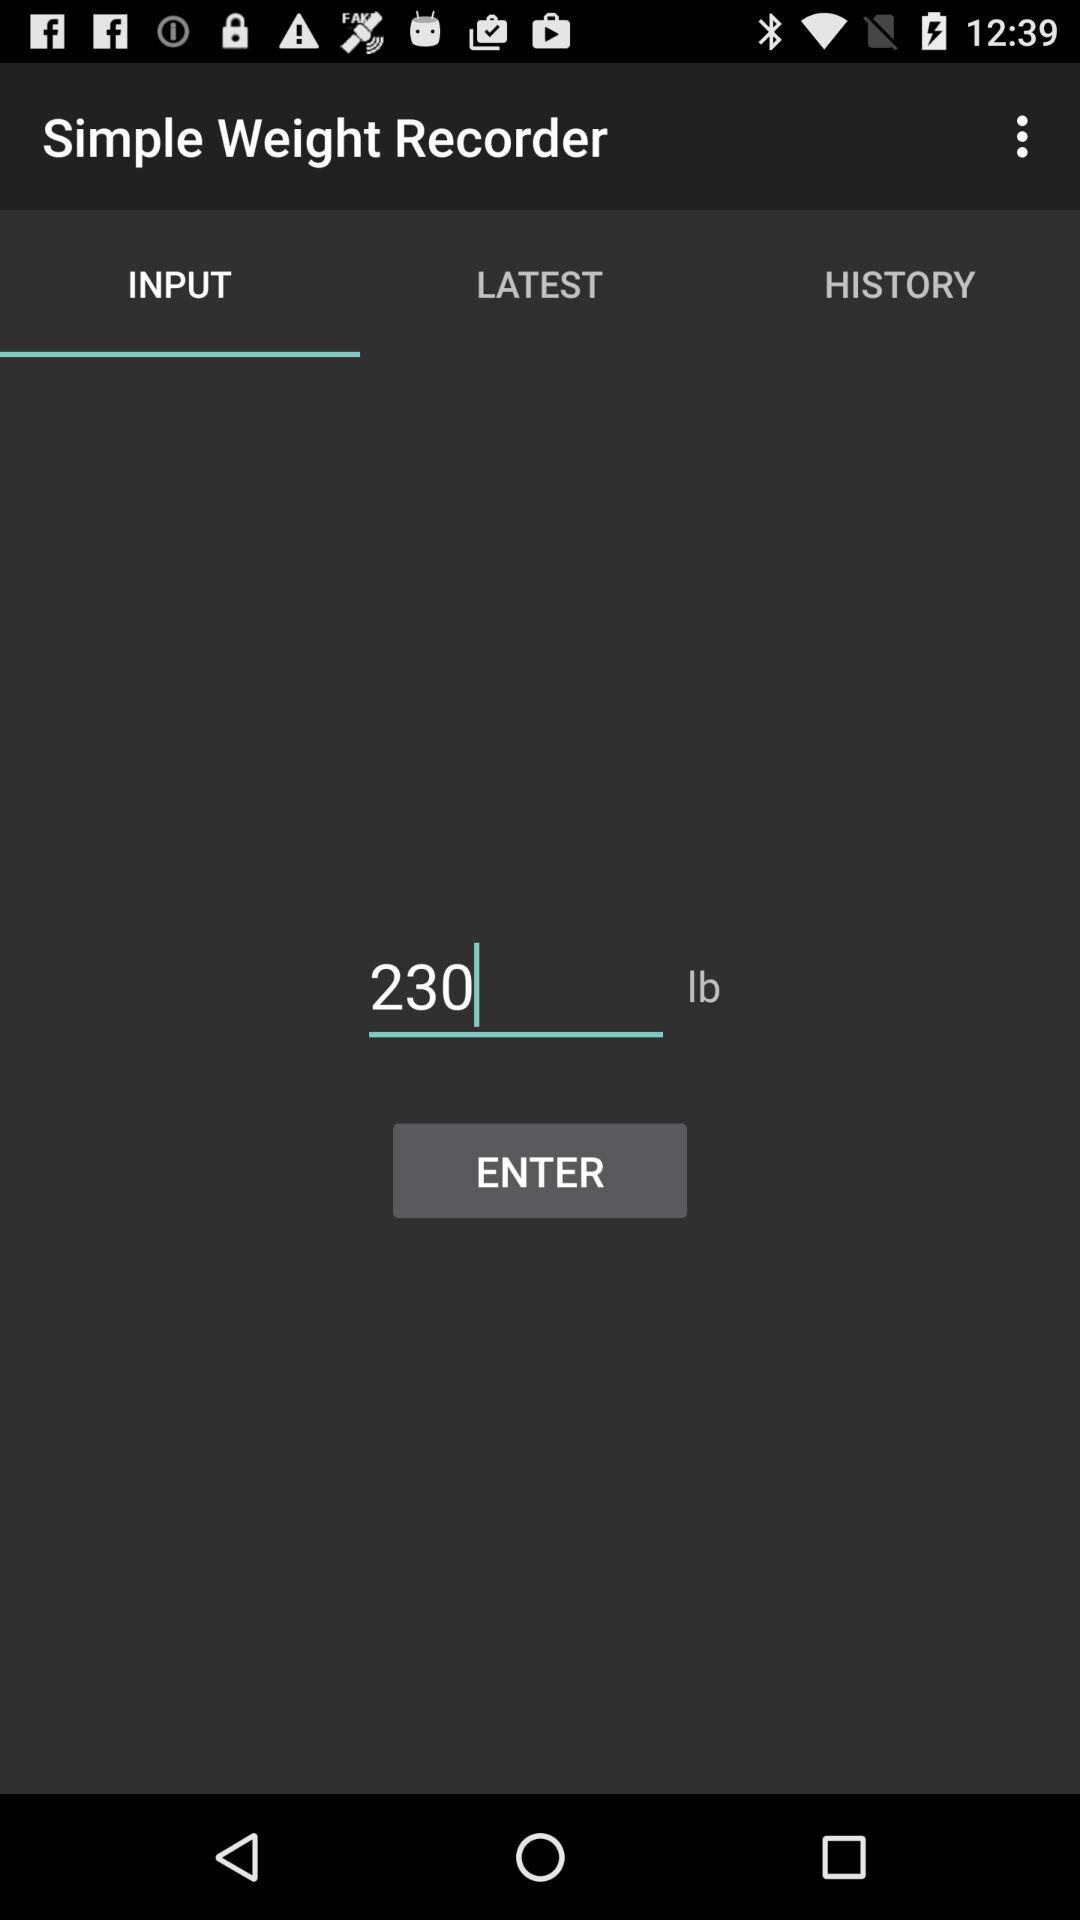Which text is entered in the input field? The entered text is "230". 